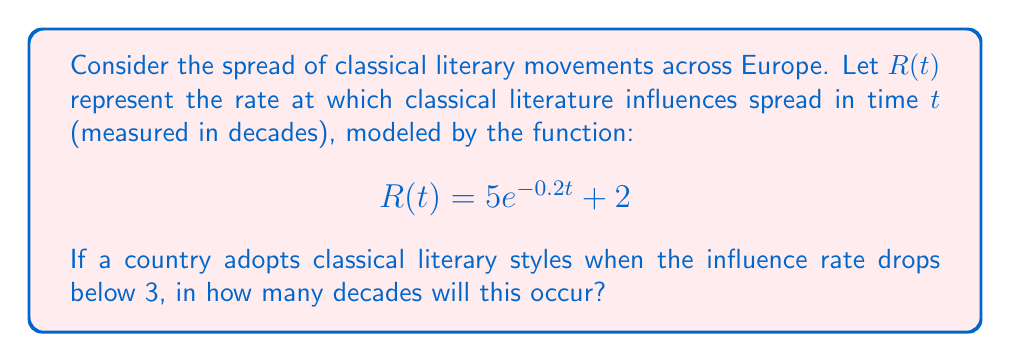Give your solution to this math problem. To solve this problem, we need to follow these steps:

1) We are looking for the time $t$ when $R(t) = 3$. This can be expressed as an equation:

   $$5e^{-0.2t} + 2 = 3$$

2) Subtract 2 from both sides:

   $$5e^{-0.2t} = 1$$

3) Divide both sides by 5:

   $$e^{-0.2t} = \frac{1}{5}$$

4) Take the natural logarithm of both sides:

   $$-0.2t = \ln(\frac{1}{5})$$

5) Divide both sides by -0.2:

   $$t = -\frac{\ln(\frac{1}{5})}{0.2}$$

6) Simplify:
   
   $$t = \frac{\ln(5)}{0.2} \approx 8.047$$

Therefore, it will take approximately 8.047 decades for the influence rate to drop below 3.
Answer: $\frac{\ln(5)}{0.2}$ decades 